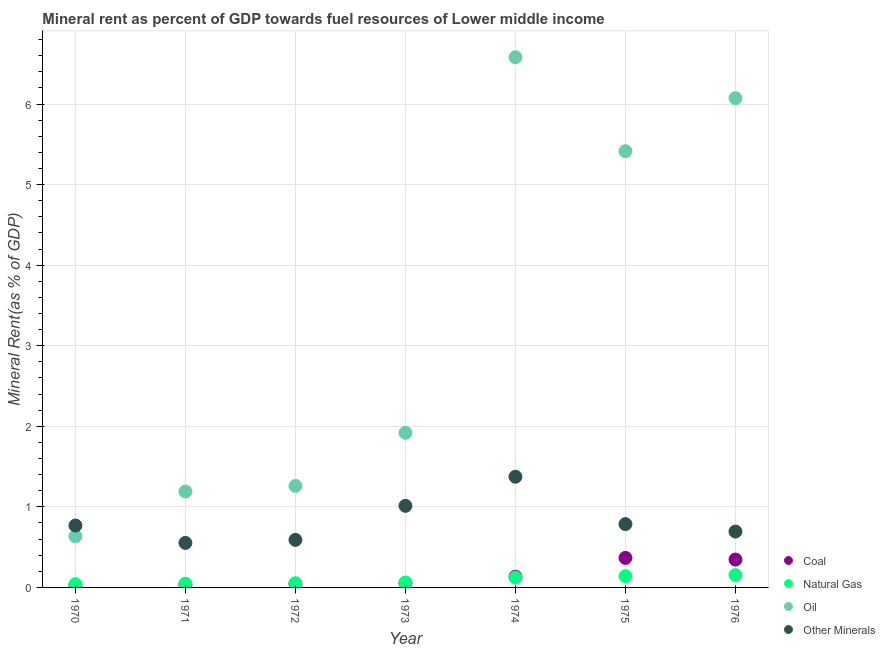Is the number of dotlines equal to the number of legend labels?
Provide a succinct answer. Yes. What is the  rent of other minerals in 1975?
Your response must be concise. 0.79. Across all years, what is the maximum natural gas rent?
Provide a succinct answer. 0.15. Across all years, what is the minimum  rent of other minerals?
Offer a terse response. 0.55. In which year was the  rent of other minerals maximum?
Keep it short and to the point. 1974. In which year was the  rent of other minerals minimum?
Offer a terse response. 1971. What is the total coal rent in the graph?
Offer a very short reply. 1. What is the difference between the natural gas rent in 1970 and that in 1975?
Your response must be concise. -0.1. What is the difference between the oil rent in 1976 and the natural gas rent in 1970?
Provide a succinct answer. 6.03. What is the average oil rent per year?
Keep it short and to the point. 3.3. In the year 1976, what is the difference between the coal rent and  rent of other minerals?
Offer a terse response. -0.35. In how many years, is the coal rent greater than 4.2 %?
Offer a terse response. 0. What is the ratio of the coal rent in 1972 to that in 1976?
Make the answer very short. 0.13. Is the difference between the coal rent in 1971 and 1976 greater than the difference between the  rent of other minerals in 1971 and 1976?
Give a very brief answer. No. What is the difference between the highest and the second highest coal rent?
Provide a short and direct response. 0.02. What is the difference between the highest and the lowest  rent of other minerals?
Your answer should be compact. 0.82. Is the oil rent strictly greater than the natural gas rent over the years?
Offer a terse response. Yes. Is the coal rent strictly less than the  rent of other minerals over the years?
Provide a short and direct response. Yes. How many years are there in the graph?
Provide a short and direct response. 7. What is the difference between two consecutive major ticks on the Y-axis?
Give a very brief answer. 1. Are the values on the major ticks of Y-axis written in scientific E-notation?
Give a very brief answer. No. Does the graph contain any zero values?
Keep it short and to the point. No. Does the graph contain grids?
Offer a very short reply. Yes. How many legend labels are there?
Make the answer very short. 4. How are the legend labels stacked?
Offer a very short reply. Vertical. What is the title of the graph?
Provide a short and direct response. Mineral rent as percent of GDP towards fuel resources of Lower middle income. What is the label or title of the Y-axis?
Make the answer very short. Mineral Rent(as % of GDP). What is the Mineral Rent(as % of GDP) of Coal in 1970?
Make the answer very short. 0.02. What is the Mineral Rent(as % of GDP) of Natural Gas in 1970?
Ensure brevity in your answer.  0.04. What is the Mineral Rent(as % of GDP) of Oil in 1970?
Offer a terse response. 0.63. What is the Mineral Rent(as % of GDP) of Other Minerals in 1970?
Ensure brevity in your answer.  0.77. What is the Mineral Rent(as % of GDP) in Coal in 1971?
Your answer should be compact. 0.04. What is the Mineral Rent(as % of GDP) in Natural Gas in 1971?
Give a very brief answer. 0.05. What is the Mineral Rent(as % of GDP) of Oil in 1971?
Your answer should be compact. 1.19. What is the Mineral Rent(as % of GDP) in Other Minerals in 1971?
Your answer should be very brief. 0.55. What is the Mineral Rent(as % of GDP) in Coal in 1972?
Ensure brevity in your answer.  0.04. What is the Mineral Rent(as % of GDP) in Natural Gas in 1972?
Your answer should be compact. 0.05. What is the Mineral Rent(as % of GDP) of Oil in 1972?
Keep it short and to the point. 1.26. What is the Mineral Rent(as % of GDP) of Other Minerals in 1972?
Offer a very short reply. 0.59. What is the Mineral Rent(as % of GDP) in Coal in 1973?
Keep it short and to the point. 0.05. What is the Mineral Rent(as % of GDP) of Natural Gas in 1973?
Make the answer very short. 0.06. What is the Mineral Rent(as % of GDP) in Oil in 1973?
Keep it short and to the point. 1.92. What is the Mineral Rent(as % of GDP) of Other Minerals in 1973?
Make the answer very short. 1.01. What is the Mineral Rent(as % of GDP) of Coal in 1974?
Provide a succinct answer. 0.13. What is the Mineral Rent(as % of GDP) of Natural Gas in 1974?
Offer a terse response. 0.12. What is the Mineral Rent(as % of GDP) of Oil in 1974?
Your response must be concise. 6.58. What is the Mineral Rent(as % of GDP) in Other Minerals in 1974?
Ensure brevity in your answer.  1.37. What is the Mineral Rent(as % of GDP) in Coal in 1975?
Your answer should be very brief. 0.37. What is the Mineral Rent(as % of GDP) of Natural Gas in 1975?
Offer a terse response. 0.14. What is the Mineral Rent(as % of GDP) of Oil in 1975?
Keep it short and to the point. 5.41. What is the Mineral Rent(as % of GDP) of Other Minerals in 1975?
Provide a succinct answer. 0.79. What is the Mineral Rent(as % of GDP) in Coal in 1976?
Your response must be concise. 0.35. What is the Mineral Rent(as % of GDP) of Natural Gas in 1976?
Ensure brevity in your answer.  0.15. What is the Mineral Rent(as % of GDP) in Oil in 1976?
Keep it short and to the point. 6.07. What is the Mineral Rent(as % of GDP) of Other Minerals in 1976?
Offer a terse response. 0.69. Across all years, what is the maximum Mineral Rent(as % of GDP) of Coal?
Keep it short and to the point. 0.37. Across all years, what is the maximum Mineral Rent(as % of GDP) of Natural Gas?
Your answer should be very brief. 0.15. Across all years, what is the maximum Mineral Rent(as % of GDP) in Oil?
Your response must be concise. 6.58. Across all years, what is the maximum Mineral Rent(as % of GDP) of Other Minerals?
Make the answer very short. 1.37. Across all years, what is the minimum Mineral Rent(as % of GDP) in Coal?
Make the answer very short. 0.02. Across all years, what is the minimum Mineral Rent(as % of GDP) of Natural Gas?
Give a very brief answer. 0.04. Across all years, what is the minimum Mineral Rent(as % of GDP) of Oil?
Keep it short and to the point. 0.63. Across all years, what is the minimum Mineral Rent(as % of GDP) of Other Minerals?
Provide a short and direct response. 0.55. What is the total Mineral Rent(as % of GDP) in Natural Gas in the graph?
Offer a terse response. 0.62. What is the total Mineral Rent(as % of GDP) in Oil in the graph?
Make the answer very short. 23.07. What is the total Mineral Rent(as % of GDP) of Other Minerals in the graph?
Make the answer very short. 5.78. What is the difference between the Mineral Rent(as % of GDP) in Coal in 1970 and that in 1971?
Give a very brief answer. -0.02. What is the difference between the Mineral Rent(as % of GDP) of Natural Gas in 1970 and that in 1971?
Offer a very short reply. -0. What is the difference between the Mineral Rent(as % of GDP) in Oil in 1970 and that in 1971?
Your response must be concise. -0.56. What is the difference between the Mineral Rent(as % of GDP) in Other Minerals in 1970 and that in 1971?
Provide a succinct answer. 0.22. What is the difference between the Mineral Rent(as % of GDP) of Coal in 1970 and that in 1972?
Give a very brief answer. -0.02. What is the difference between the Mineral Rent(as % of GDP) of Natural Gas in 1970 and that in 1972?
Your answer should be very brief. -0.01. What is the difference between the Mineral Rent(as % of GDP) of Oil in 1970 and that in 1972?
Provide a succinct answer. -0.62. What is the difference between the Mineral Rent(as % of GDP) in Other Minerals in 1970 and that in 1972?
Keep it short and to the point. 0.18. What is the difference between the Mineral Rent(as % of GDP) of Coal in 1970 and that in 1973?
Provide a succinct answer. -0.03. What is the difference between the Mineral Rent(as % of GDP) of Natural Gas in 1970 and that in 1973?
Your response must be concise. -0.02. What is the difference between the Mineral Rent(as % of GDP) of Oil in 1970 and that in 1973?
Make the answer very short. -1.28. What is the difference between the Mineral Rent(as % of GDP) of Other Minerals in 1970 and that in 1973?
Your answer should be very brief. -0.24. What is the difference between the Mineral Rent(as % of GDP) of Coal in 1970 and that in 1974?
Provide a short and direct response. -0.11. What is the difference between the Mineral Rent(as % of GDP) of Natural Gas in 1970 and that in 1974?
Ensure brevity in your answer.  -0.08. What is the difference between the Mineral Rent(as % of GDP) of Oil in 1970 and that in 1974?
Ensure brevity in your answer.  -5.95. What is the difference between the Mineral Rent(as % of GDP) in Other Minerals in 1970 and that in 1974?
Your answer should be very brief. -0.61. What is the difference between the Mineral Rent(as % of GDP) in Coal in 1970 and that in 1975?
Ensure brevity in your answer.  -0.35. What is the difference between the Mineral Rent(as % of GDP) of Natural Gas in 1970 and that in 1975?
Provide a short and direct response. -0.1. What is the difference between the Mineral Rent(as % of GDP) in Oil in 1970 and that in 1975?
Your answer should be very brief. -4.78. What is the difference between the Mineral Rent(as % of GDP) in Other Minerals in 1970 and that in 1975?
Your response must be concise. -0.02. What is the difference between the Mineral Rent(as % of GDP) of Coal in 1970 and that in 1976?
Offer a very short reply. -0.33. What is the difference between the Mineral Rent(as % of GDP) of Natural Gas in 1970 and that in 1976?
Your answer should be compact. -0.11. What is the difference between the Mineral Rent(as % of GDP) of Oil in 1970 and that in 1976?
Your answer should be very brief. -5.44. What is the difference between the Mineral Rent(as % of GDP) in Other Minerals in 1970 and that in 1976?
Offer a terse response. 0.08. What is the difference between the Mineral Rent(as % of GDP) in Coal in 1971 and that in 1972?
Your answer should be compact. -0.01. What is the difference between the Mineral Rent(as % of GDP) of Natural Gas in 1971 and that in 1972?
Offer a very short reply. -0.01. What is the difference between the Mineral Rent(as % of GDP) of Oil in 1971 and that in 1972?
Ensure brevity in your answer.  -0.07. What is the difference between the Mineral Rent(as % of GDP) of Other Minerals in 1971 and that in 1972?
Your answer should be very brief. -0.04. What is the difference between the Mineral Rent(as % of GDP) in Coal in 1971 and that in 1973?
Ensure brevity in your answer.  -0.02. What is the difference between the Mineral Rent(as % of GDP) of Natural Gas in 1971 and that in 1973?
Provide a succinct answer. -0.02. What is the difference between the Mineral Rent(as % of GDP) in Oil in 1971 and that in 1973?
Your answer should be compact. -0.73. What is the difference between the Mineral Rent(as % of GDP) in Other Minerals in 1971 and that in 1973?
Offer a very short reply. -0.46. What is the difference between the Mineral Rent(as % of GDP) of Coal in 1971 and that in 1974?
Provide a short and direct response. -0.1. What is the difference between the Mineral Rent(as % of GDP) in Natural Gas in 1971 and that in 1974?
Make the answer very short. -0.08. What is the difference between the Mineral Rent(as % of GDP) in Oil in 1971 and that in 1974?
Offer a terse response. -5.39. What is the difference between the Mineral Rent(as % of GDP) in Other Minerals in 1971 and that in 1974?
Keep it short and to the point. -0.82. What is the difference between the Mineral Rent(as % of GDP) of Coal in 1971 and that in 1975?
Provide a succinct answer. -0.33. What is the difference between the Mineral Rent(as % of GDP) of Natural Gas in 1971 and that in 1975?
Offer a terse response. -0.09. What is the difference between the Mineral Rent(as % of GDP) in Oil in 1971 and that in 1975?
Ensure brevity in your answer.  -4.22. What is the difference between the Mineral Rent(as % of GDP) in Other Minerals in 1971 and that in 1975?
Provide a short and direct response. -0.23. What is the difference between the Mineral Rent(as % of GDP) of Coal in 1971 and that in 1976?
Provide a succinct answer. -0.31. What is the difference between the Mineral Rent(as % of GDP) in Natural Gas in 1971 and that in 1976?
Provide a succinct answer. -0.11. What is the difference between the Mineral Rent(as % of GDP) of Oil in 1971 and that in 1976?
Give a very brief answer. -4.88. What is the difference between the Mineral Rent(as % of GDP) in Other Minerals in 1971 and that in 1976?
Give a very brief answer. -0.14. What is the difference between the Mineral Rent(as % of GDP) in Coal in 1972 and that in 1973?
Provide a short and direct response. -0.01. What is the difference between the Mineral Rent(as % of GDP) in Natural Gas in 1972 and that in 1973?
Your answer should be compact. -0.01. What is the difference between the Mineral Rent(as % of GDP) of Oil in 1972 and that in 1973?
Offer a terse response. -0.66. What is the difference between the Mineral Rent(as % of GDP) in Other Minerals in 1972 and that in 1973?
Ensure brevity in your answer.  -0.42. What is the difference between the Mineral Rent(as % of GDP) of Coal in 1972 and that in 1974?
Your answer should be very brief. -0.09. What is the difference between the Mineral Rent(as % of GDP) in Natural Gas in 1972 and that in 1974?
Your response must be concise. -0.07. What is the difference between the Mineral Rent(as % of GDP) of Oil in 1972 and that in 1974?
Offer a very short reply. -5.32. What is the difference between the Mineral Rent(as % of GDP) of Other Minerals in 1972 and that in 1974?
Offer a very short reply. -0.78. What is the difference between the Mineral Rent(as % of GDP) in Coal in 1972 and that in 1975?
Offer a terse response. -0.32. What is the difference between the Mineral Rent(as % of GDP) in Natural Gas in 1972 and that in 1975?
Your answer should be very brief. -0.09. What is the difference between the Mineral Rent(as % of GDP) in Oil in 1972 and that in 1975?
Give a very brief answer. -4.15. What is the difference between the Mineral Rent(as % of GDP) in Other Minerals in 1972 and that in 1975?
Provide a short and direct response. -0.2. What is the difference between the Mineral Rent(as % of GDP) in Coal in 1972 and that in 1976?
Give a very brief answer. -0.3. What is the difference between the Mineral Rent(as % of GDP) of Natural Gas in 1972 and that in 1976?
Your answer should be very brief. -0.1. What is the difference between the Mineral Rent(as % of GDP) of Oil in 1972 and that in 1976?
Provide a succinct answer. -4.81. What is the difference between the Mineral Rent(as % of GDP) of Other Minerals in 1972 and that in 1976?
Ensure brevity in your answer.  -0.1. What is the difference between the Mineral Rent(as % of GDP) of Coal in 1973 and that in 1974?
Provide a succinct answer. -0.08. What is the difference between the Mineral Rent(as % of GDP) of Natural Gas in 1973 and that in 1974?
Provide a short and direct response. -0.06. What is the difference between the Mineral Rent(as % of GDP) in Oil in 1973 and that in 1974?
Keep it short and to the point. -4.66. What is the difference between the Mineral Rent(as % of GDP) in Other Minerals in 1973 and that in 1974?
Make the answer very short. -0.36. What is the difference between the Mineral Rent(as % of GDP) of Coal in 1973 and that in 1975?
Your response must be concise. -0.31. What is the difference between the Mineral Rent(as % of GDP) in Natural Gas in 1973 and that in 1975?
Give a very brief answer. -0.08. What is the difference between the Mineral Rent(as % of GDP) of Oil in 1973 and that in 1975?
Offer a very short reply. -3.5. What is the difference between the Mineral Rent(as % of GDP) in Other Minerals in 1973 and that in 1975?
Offer a terse response. 0.23. What is the difference between the Mineral Rent(as % of GDP) in Coal in 1973 and that in 1976?
Provide a succinct answer. -0.29. What is the difference between the Mineral Rent(as % of GDP) in Natural Gas in 1973 and that in 1976?
Your answer should be compact. -0.09. What is the difference between the Mineral Rent(as % of GDP) in Oil in 1973 and that in 1976?
Provide a succinct answer. -4.15. What is the difference between the Mineral Rent(as % of GDP) in Other Minerals in 1973 and that in 1976?
Keep it short and to the point. 0.32. What is the difference between the Mineral Rent(as % of GDP) of Coal in 1974 and that in 1975?
Provide a succinct answer. -0.23. What is the difference between the Mineral Rent(as % of GDP) in Natural Gas in 1974 and that in 1975?
Provide a succinct answer. -0.02. What is the difference between the Mineral Rent(as % of GDP) of Oil in 1974 and that in 1975?
Offer a terse response. 1.17. What is the difference between the Mineral Rent(as % of GDP) of Other Minerals in 1974 and that in 1975?
Make the answer very short. 0.59. What is the difference between the Mineral Rent(as % of GDP) of Coal in 1974 and that in 1976?
Keep it short and to the point. -0.21. What is the difference between the Mineral Rent(as % of GDP) in Natural Gas in 1974 and that in 1976?
Offer a very short reply. -0.03. What is the difference between the Mineral Rent(as % of GDP) in Oil in 1974 and that in 1976?
Your answer should be compact. 0.51. What is the difference between the Mineral Rent(as % of GDP) in Other Minerals in 1974 and that in 1976?
Your answer should be compact. 0.68. What is the difference between the Mineral Rent(as % of GDP) of Coal in 1975 and that in 1976?
Offer a very short reply. 0.02. What is the difference between the Mineral Rent(as % of GDP) of Natural Gas in 1975 and that in 1976?
Give a very brief answer. -0.01. What is the difference between the Mineral Rent(as % of GDP) of Oil in 1975 and that in 1976?
Provide a succinct answer. -0.66. What is the difference between the Mineral Rent(as % of GDP) of Other Minerals in 1975 and that in 1976?
Make the answer very short. 0.09. What is the difference between the Mineral Rent(as % of GDP) of Coal in 1970 and the Mineral Rent(as % of GDP) of Natural Gas in 1971?
Your answer should be very brief. -0.03. What is the difference between the Mineral Rent(as % of GDP) of Coal in 1970 and the Mineral Rent(as % of GDP) of Oil in 1971?
Provide a succinct answer. -1.17. What is the difference between the Mineral Rent(as % of GDP) in Coal in 1970 and the Mineral Rent(as % of GDP) in Other Minerals in 1971?
Make the answer very short. -0.53. What is the difference between the Mineral Rent(as % of GDP) in Natural Gas in 1970 and the Mineral Rent(as % of GDP) in Oil in 1971?
Provide a succinct answer. -1.15. What is the difference between the Mineral Rent(as % of GDP) of Natural Gas in 1970 and the Mineral Rent(as % of GDP) of Other Minerals in 1971?
Give a very brief answer. -0.51. What is the difference between the Mineral Rent(as % of GDP) in Oil in 1970 and the Mineral Rent(as % of GDP) in Other Minerals in 1971?
Your answer should be very brief. 0.08. What is the difference between the Mineral Rent(as % of GDP) of Coal in 1970 and the Mineral Rent(as % of GDP) of Natural Gas in 1972?
Offer a terse response. -0.03. What is the difference between the Mineral Rent(as % of GDP) of Coal in 1970 and the Mineral Rent(as % of GDP) of Oil in 1972?
Your response must be concise. -1.24. What is the difference between the Mineral Rent(as % of GDP) in Coal in 1970 and the Mineral Rent(as % of GDP) in Other Minerals in 1972?
Your answer should be compact. -0.57. What is the difference between the Mineral Rent(as % of GDP) in Natural Gas in 1970 and the Mineral Rent(as % of GDP) in Oil in 1972?
Make the answer very short. -1.22. What is the difference between the Mineral Rent(as % of GDP) of Natural Gas in 1970 and the Mineral Rent(as % of GDP) of Other Minerals in 1972?
Your answer should be compact. -0.55. What is the difference between the Mineral Rent(as % of GDP) of Oil in 1970 and the Mineral Rent(as % of GDP) of Other Minerals in 1972?
Keep it short and to the point. 0.04. What is the difference between the Mineral Rent(as % of GDP) of Coal in 1970 and the Mineral Rent(as % of GDP) of Natural Gas in 1973?
Give a very brief answer. -0.04. What is the difference between the Mineral Rent(as % of GDP) in Coal in 1970 and the Mineral Rent(as % of GDP) in Oil in 1973?
Your response must be concise. -1.9. What is the difference between the Mineral Rent(as % of GDP) of Coal in 1970 and the Mineral Rent(as % of GDP) of Other Minerals in 1973?
Offer a terse response. -0.99. What is the difference between the Mineral Rent(as % of GDP) of Natural Gas in 1970 and the Mineral Rent(as % of GDP) of Oil in 1973?
Your response must be concise. -1.88. What is the difference between the Mineral Rent(as % of GDP) in Natural Gas in 1970 and the Mineral Rent(as % of GDP) in Other Minerals in 1973?
Ensure brevity in your answer.  -0.97. What is the difference between the Mineral Rent(as % of GDP) in Oil in 1970 and the Mineral Rent(as % of GDP) in Other Minerals in 1973?
Your response must be concise. -0.38. What is the difference between the Mineral Rent(as % of GDP) in Coal in 1970 and the Mineral Rent(as % of GDP) in Natural Gas in 1974?
Your answer should be very brief. -0.1. What is the difference between the Mineral Rent(as % of GDP) of Coal in 1970 and the Mineral Rent(as % of GDP) of Oil in 1974?
Make the answer very short. -6.56. What is the difference between the Mineral Rent(as % of GDP) in Coal in 1970 and the Mineral Rent(as % of GDP) in Other Minerals in 1974?
Your answer should be very brief. -1.35. What is the difference between the Mineral Rent(as % of GDP) in Natural Gas in 1970 and the Mineral Rent(as % of GDP) in Oil in 1974?
Offer a very short reply. -6.54. What is the difference between the Mineral Rent(as % of GDP) in Natural Gas in 1970 and the Mineral Rent(as % of GDP) in Other Minerals in 1974?
Offer a very short reply. -1.33. What is the difference between the Mineral Rent(as % of GDP) in Oil in 1970 and the Mineral Rent(as % of GDP) in Other Minerals in 1974?
Ensure brevity in your answer.  -0.74. What is the difference between the Mineral Rent(as % of GDP) of Coal in 1970 and the Mineral Rent(as % of GDP) of Natural Gas in 1975?
Make the answer very short. -0.12. What is the difference between the Mineral Rent(as % of GDP) in Coal in 1970 and the Mineral Rent(as % of GDP) in Oil in 1975?
Offer a very short reply. -5.39. What is the difference between the Mineral Rent(as % of GDP) in Coal in 1970 and the Mineral Rent(as % of GDP) in Other Minerals in 1975?
Provide a short and direct response. -0.77. What is the difference between the Mineral Rent(as % of GDP) in Natural Gas in 1970 and the Mineral Rent(as % of GDP) in Oil in 1975?
Provide a short and direct response. -5.37. What is the difference between the Mineral Rent(as % of GDP) in Natural Gas in 1970 and the Mineral Rent(as % of GDP) in Other Minerals in 1975?
Provide a short and direct response. -0.74. What is the difference between the Mineral Rent(as % of GDP) of Oil in 1970 and the Mineral Rent(as % of GDP) of Other Minerals in 1975?
Ensure brevity in your answer.  -0.15. What is the difference between the Mineral Rent(as % of GDP) in Coal in 1970 and the Mineral Rent(as % of GDP) in Natural Gas in 1976?
Give a very brief answer. -0.13. What is the difference between the Mineral Rent(as % of GDP) in Coal in 1970 and the Mineral Rent(as % of GDP) in Oil in 1976?
Provide a succinct answer. -6.05. What is the difference between the Mineral Rent(as % of GDP) in Coal in 1970 and the Mineral Rent(as % of GDP) in Other Minerals in 1976?
Offer a terse response. -0.67. What is the difference between the Mineral Rent(as % of GDP) in Natural Gas in 1970 and the Mineral Rent(as % of GDP) in Oil in 1976?
Give a very brief answer. -6.03. What is the difference between the Mineral Rent(as % of GDP) in Natural Gas in 1970 and the Mineral Rent(as % of GDP) in Other Minerals in 1976?
Your answer should be very brief. -0.65. What is the difference between the Mineral Rent(as % of GDP) in Oil in 1970 and the Mineral Rent(as % of GDP) in Other Minerals in 1976?
Keep it short and to the point. -0.06. What is the difference between the Mineral Rent(as % of GDP) in Coal in 1971 and the Mineral Rent(as % of GDP) in Natural Gas in 1972?
Provide a short and direct response. -0.02. What is the difference between the Mineral Rent(as % of GDP) of Coal in 1971 and the Mineral Rent(as % of GDP) of Oil in 1972?
Keep it short and to the point. -1.22. What is the difference between the Mineral Rent(as % of GDP) of Coal in 1971 and the Mineral Rent(as % of GDP) of Other Minerals in 1972?
Provide a succinct answer. -0.55. What is the difference between the Mineral Rent(as % of GDP) in Natural Gas in 1971 and the Mineral Rent(as % of GDP) in Oil in 1972?
Offer a terse response. -1.21. What is the difference between the Mineral Rent(as % of GDP) in Natural Gas in 1971 and the Mineral Rent(as % of GDP) in Other Minerals in 1972?
Ensure brevity in your answer.  -0.54. What is the difference between the Mineral Rent(as % of GDP) of Oil in 1971 and the Mineral Rent(as % of GDP) of Other Minerals in 1972?
Your answer should be compact. 0.6. What is the difference between the Mineral Rent(as % of GDP) of Coal in 1971 and the Mineral Rent(as % of GDP) of Natural Gas in 1973?
Your answer should be compact. -0.02. What is the difference between the Mineral Rent(as % of GDP) of Coal in 1971 and the Mineral Rent(as % of GDP) of Oil in 1973?
Provide a succinct answer. -1.88. What is the difference between the Mineral Rent(as % of GDP) in Coal in 1971 and the Mineral Rent(as % of GDP) in Other Minerals in 1973?
Your answer should be very brief. -0.98. What is the difference between the Mineral Rent(as % of GDP) of Natural Gas in 1971 and the Mineral Rent(as % of GDP) of Oil in 1973?
Ensure brevity in your answer.  -1.87. What is the difference between the Mineral Rent(as % of GDP) of Natural Gas in 1971 and the Mineral Rent(as % of GDP) of Other Minerals in 1973?
Give a very brief answer. -0.97. What is the difference between the Mineral Rent(as % of GDP) of Oil in 1971 and the Mineral Rent(as % of GDP) of Other Minerals in 1973?
Your answer should be compact. 0.18. What is the difference between the Mineral Rent(as % of GDP) of Coal in 1971 and the Mineral Rent(as % of GDP) of Natural Gas in 1974?
Keep it short and to the point. -0.09. What is the difference between the Mineral Rent(as % of GDP) in Coal in 1971 and the Mineral Rent(as % of GDP) in Oil in 1974?
Keep it short and to the point. -6.54. What is the difference between the Mineral Rent(as % of GDP) of Coal in 1971 and the Mineral Rent(as % of GDP) of Other Minerals in 1974?
Your response must be concise. -1.34. What is the difference between the Mineral Rent(as % of GDP) in Natural Gas in 1971 and the Mineral Rent(as % of GDP) in Oil in 1974?
Keep it short and to the point. -6.53. What is the difference between the Mineral Rent(as % of GDP) of Natural Gas in 1971 and the Mineral Rent(as % of GDP) of Other Minerals in 1974?
Provide a short and direct response. -1.33. What is the difference between the Mineral Rent(as % of GDP) in Oil in 1971 and the Mineral Rent(as % of GDP) in Other Minerals in 1974?
Your answer should be very brief. -0.18. What is the difference between the Mineral Rent(as % of GDP) of Coal in 1971 and the Mineral Rent(as % of GDP) of Natural Gas in 1975?
Offer a terse response. -0.1. What is the difference between the Mineral Rent(as % of GDP) in Coal in 1971 and the Mineral Rent(as % of GDP) in Oil in 1975?
Offer a terse response. -5.38. What is the difference between the Mineral Rent(as % of GDP) in Coal in 1971 and the Mineral Rent(as % of GDP) in Other Minerals in 1975?
Your answer should be very brief. -0.75. What is the difference between the Mineral Rent(as % of GDP) of Natural Gas in 1971 and the Mineral Rent(as % of GDP) of Oil in 1975?
Offer a terse response. -5.37. What is the difference between the Mineral Rent(as % of GDP) in Natural Gas in 1971 and the Mineral Rent(as % of GDP) in Other Minerals in 1975?
Ensure brevity in your answer.  -0.74. What is the difference between the Mineral Rent(as % of GDP) in Oil in 1971 and the Mineral Rent(as % of GDP) in Other Minerals in 1975?
Offer a terse response. 0.4. What is the difference between the Mineral Rent(as % of GDP) in Coal in 1971 and the Mineral Rent(as % of GDP) in Natural Gas in 1976?
Offer a terse response. -0.12. What is the difference between the Mineral Rent(as % of GDP) of Coal in 1971 and the Mineral Rent(as % of GDP) of Oil in 1976?
Provide a succinct answer. -6.04. What is the difference between the Mineral Rent(as % of GDP) of Coal in 1971 and the Mineral Rent(as % of GDP) of Other Minerals in 1976?
Offer a very short reply. -0.66. What is the difference between the Mineral Rent(as % of GDP) in Natural Gas in 1971 and the Mineral Rent(as % of GDP) in Oil in 1976?
Provide a short and direct response. -6.03. What is the difference between the Mineral Rent(as % of GDP) in Natural Gas in 1971 and the Mineral Rent(as % of GDP) in Other Minerals in 1976?
Make the answer very short. -0.65. What is the difference between the Mineral Rent(as % of GDP) in Oil in 1971 and the Mineral Rent(as % of GDP) in Other Minerals in 1976?
Provide a short and direct response. 0.5. What is the difference between the Mineral Rent(as % of GDP) of Coal in 1972 and the Mineral Rent(as % of GDP) of Natural Gas in 1973?
Your answer should be compact. -0.02. What is the difference between the Mineral Rent(as % of GDP) of Coal in 1972 and the Mineral Rent(as % of GDP) of Oil in 1973?
Your answer should be very brief. -1.87. What is the difference between the Mineral Rent(as % of GDP) of Coal in 1972 and the Mineral Rent(as % of GDP) of Other Minerals in 1973?
Your answer should be compact. -0.97. What is the difference between the Mineral Rent(as % of GDP) in Natural Gas in 1972 and the Mineral Rent(as % of GDP) in Oil in 1973?
Offer a terse response. -1.87. What is the difference between the Mineral Rent(as % of GDP) of Natural Gas in 1972 and the Mineral Rent(as % of GDP) of Other Minerals in 1973?
Provide a succinct answer. -0.96. What is the difference between the Mineral Rent(as % of GDP) in Oil in 1972 and the Mineral Rent(as % of GDP) in Other Minerals in 1973?
Make the answer very short. 0.25. What is the difference between the Mineral Rent(as % of GDP) of Coal in 1972 and the Mineral Rent(as % of GDP) of Natural Gas in 1974?
Make the answer very short. -0.08. What is the difference between the Mineral Rent(as % of GDP) of Coal in 1972 and the Mineral Rent(as % of GDP) of Oil in 1974?
Your answer should be compact. -6.54. What is the difference between the Mineral Rent(as % of GDP) of Coal in 1972 and the Mineral Rent(as % of GDP) of Other Minerals in 1974?
Provide a succinct answer. -1.33. What is the difference between the Mineral Rent(as % of GDP) in Natural Gas in 1972 and the Mineral Rent(as % of GDP) in Oil in 1974?
Make the answer very short. -6.53. What is the difference between the Mineral Rent(as % of GDP) in Natural Gas in 1972 and the Mineral Rent(as % of GDP) in Other Minerals in 1974?
Your response must be concise. -1.32. What is the difference between the Mineral Rent(as % of GDP) of Oil in 1972 and the Mineral Rent(as % of GDP) of Other Minerals in 1974?
Give a very brief answer. -0.11. What is the difference between the Mineral Rent(as % of GDP) of Coal in 1972 and the Mineral Rent(as % of GDP) of Natural Gas in 1975?
Make the answer very short. -0.1. What is the difference between the Mineral Rent(as % of GDP) in Coal in 1972 and the Mineral Rent(as % of GDP) in Oil in 1975?
Keep it short and to the point. -5.37. What is the difference between the Mineral Rent(as % of GDP) of Coal in 1972 and the Mineral Rent(as % of GDP) of Other Minerals in 1975?
Provide a succinct answer. -0.74. What is the difference between the Mineral Rent(as % of GDP) in Natural Gas in 1972 and the Mineral Rent(as % of GDP) in Oil in 1975?
Offer a very short reply. -5.36. What is the difference between the Mineral Rent(as % of GDP) of Natural Gas in 1972 and the Mineral Rent(as % of GDP) of Other Minerals in 1975?
Provide a short and direct response. -0.73. What is the difference between the Mineral Rent(as % of GDP) in Oil in 1972 and the Mineral Rent(as % of GDP) in Other Minerals in 1975?
Provide a short and direct response. 0.47. What is the difference between the Mineral Rent(as % of GDP) in Coal in 1972 and the Mineral Rent(as % of GDP) in Natural Gas in 1976?
Keep it short and to the point. -0.11. What is the difference between the Mineral Rent(as % of GDP) in Coal in 1972 and the Mineral Rent(as % of GDP) in Oil in 1976?
Keep it short and to the point. -6.03. What is the difference between the Mineral Rent(as % of GDP) in Coal in 1972 and the Mineral Rent(as % of GDP) in Other Minerals in 1976?
Ensure brevity in your answer.  -0.65. What is the difference between the Mineral Rent(as % of GDP) of Natural Gas in 1972 and the Mineral Rent(as % of GDP) of Oil in 1976?
Your answer should be compact. -6.02. What is the difference between the Mineral Rent(as % of GDP) of Natural Gas in 1972 and the Mineral Rent(as % of GDP) of Other Minerals in 1976?
Ensure brevity in your answer.  -0.64. What is the difference between the Mineral Rent(as % of GDP) in Oil in 1972 and the Mineral Rent(as % of GDP) in Other Minerals in 1976?
Your response must be concise. 0.57. What is the difference between the Mineral Rent(as % of GDP) in Coal in 1973 and the Mineral Rent(as % of GDP) in Natural Gas in 1974?
Keep it short and to the point. -0.07. What is the difference between the Mineral Rent(as % of GDP) of Coal in 1973 and the Mineral Rent(as % of GDP) of Oil in 1974?
Provide a succinct answer. -6.53. What is the difference between the Mineral Rent(as % of GDP) in Coal in 1973 and the Mineral Rent(as % of GDP) in Other Minerals in 1974?
Your answer should be very brief. -1.32. What is the difference between the Mineral Rent(as % of GDP) of Natural Gas in 1973 and the Mineral Rent(as % of GDP) of Oil in 1974?
Your answer should be very brief. -6.52. What is the difference between the Mineral Rent(as % of GDP) of Natural Gas in 1973 and the Mineral Rent(as % of GDP) of Other Minerals in 1974?
Your answer should be compact. -1.31. What is the difference between the Mineral Rent(as % of GDP) of Oil in 1973 and the Mineral Rent(as % of GDP) of Other Minerals in 1974?
Your answer should be compact. 0.54. What is the difference between the Mineral Rent(as % of GDP) in Coal in 1973 and the Mineral Rent(as % of GDP) in Natural Gas in 1975?
Provide a short and direct response. -0.09. What is the difference between the Mineral Rent(as % of GDP) of Coal in 1973 and the Mineral Rent(as % of GDP) of Oil in 1975?
Give a very brief answer. -5.36. What is the difference between the Mineral Rent(as % of GDP) in Coal in 1973 and the Mineral Rent(as % of GDP) in Other Minerals in 1975?
Provide a succinct answer. -0.73. What is the difference between the Mineral Rent(as % of GDP) in Natural Gas in 1973 and the Mineral Rent(as % of GDP) in Oil in 1975?
Keep it short and to the point. -5.35. What is the difference between the Mineral Rent(as % of GDP) in Natural Gas in 1973 and the Mineral Rent(as % of GDP) in Other Minerals in 1975?
Provide a short and direct response. -0.72. What is the difference between the Mineral Rent(as % of GDP) in Oil in 1973 and the Mineral Rent(as % of GDP) in Other Minerals in 1975?
Your answer should be very brief. 1.13. What is the difference between the Mineral Rent(as % of GDP) of Coal in 1973 and the Mineral Rent(as % of GDP) of Natural Gas in 1976?
Your response must be concise. -0.1. What is the difference between the Mineral Rent(as % of GDP) in Coal in 1973 and the Mineral Rent(as % of GDP) in Oil in 1976?
Provide a short and direct response. -6.02. What is the difference between the Mineral Rent(as % of GDP) in Coal in 1973 and the Mineral Rent(as % of GDP) in Other Minerals in 1976?
Give a very brief answer. -0.64. What is the difference between the Mineral Rent(as % of GDP) of Natural Gas in 1973 and the Mineral Rent(as % of GDP) of Oil in 1976?
Make the answer very short. -6.01. What is the difference between the Mineral Rent(as % of GDP) in Natural Gas in 1973 and the Mineral Rent(as % of GDP) in Other Minerals in 1976?
Offer a terse response. -0.63. What is the difference between the Mineral Rent(as % of GDP) of Oil in 1973 and the Mineral Rent(as % of GDP) of Other Minerals in 1976?
Provide a short and direct response. 1.23. What is the difference between the Mineral Rent(as % of GDP) of Coal in 1974 and the Mineral Rent(as % of GDP) of Natural Gas in 1975?
Give a very brief answer. -0.01. What is the difference between the Mineral Rent(as % of GDP) of Coal in 1974 and the Mineral Rent(as % of GDP) of Oil in 1975?
Provide a short and direct response. -5.28. What is the difference between the Mineral Rent(as % of GDP) of Coal in 1974 and the Mineral Rent(as % of GDP) of Other Minerals in 1975?
Ensure brevity in your answer.  -0.65. What is the difference between the Mineral Rent(as % of GDP) in Natural Gas in 1974 and the Mineral Rent(as % of GDP) in Oil in 1975?
Your response must be concise. -5.29. What is the difference between the Mineral Rent(as % of GDP) in Natural Gas in 1974 and the Mineral Rent(as % of GDP) in Other Minerals in 1975?
Your answer should be compact. -0.66. What is the difference between the Mineral Rent(as % of GDP) of Oil in 1974 and the Mineral Rent(as % of GDP) of Other Minerals in 1975?
Provide a short and direct response. 5.79. What is the difference between the Mineral Rent(as % of GDP) of Coal in 1974 and the Mineral Rent(as % of GDP) of Natural Gas in 1976?
Ensure brevity in your answer.  -0.02. What is the difference between the Mineral Rent(as % of GDP) of Coal in 1974 and the Mineral Rent(as % of GDP) of Oil in 1976?
Make the answer very short. -5.94. What is the difference between the Mineral Rent(as % of GDP) of Coal in 1974 and the Mineral Rent(as % of GDP) of Other Minerals in 1976?
Provide a short and direct response. -0.56. What is the difference between the Mineral Rent(as % of GDP) in Natural Gas in 1974 and the Mineral Rent(as % of GDP) in Oil in 1976?
Offer a terse response. -5.95. What is the difference between the Mineral Rent(as % of GDP) in Natural Gas in 1974 and the Mineral Rent(as % of GDP) in Other Minerals in 1976?
Give a very brief answer. -0.57. What is the difference between the Mineral Rent(as % of GDP) in Oil in 1974 and the Mineral Rent(as % of GDP) in Other Minerals in 1976?
Provide a succinct answer. 5.89. What is the difference between the Mineral Rent(as % of GDP) in Coal in 1975 and the Mineral Rent(as % of GDP) in Natural Gas in 1976?
Make the answer very short. 0.21. What is the difference between the Mineral Rent(as % of GDP) in Coal in 1975 and the Mineral Rent(as % of GDP) in Oil in 1976?
Give a very brief answer. -5.71. What is the difference between the Mineral Rent(as % of GDP) in Coal in 1975 and the Mineral Rent(as % of GDP) in Other Minerals in 1976?
Ensure brevity in your answer.  -0.33. What is the difference between the Mineral Rent(as % of GDP) in Natural Gas in 1975 and the Mineral Rent(as % of GDP) in Oil in 1976?
Provide a succinct answer. -5.93. What is the difference between the Mineral Rent(as % of GDP) in Natural Gas in 1975 and the Mineral Rent(as % of GDP) in Other Minerals in 1976?
Make the answer very short. -0.55. What is the difference between the Mineral Rent(as % of GDP) in Oil in 1975 and the Mineral Rent(as % of GDP) in Other Minerals in 1976?
Offer a very short reply. 4.72. What is the average Mineral Rent(as % of GDP) in Coal per year?
Provide a succinct answer. 0.14. What is the average Mineral Rent(as % of GDP) of Natural Gas per year?
Provide a short and direct response. 0.09. What is the average Mineral Rent(as % of GDP) of Oil per year?
Your answer should be compact. 3.3. What is the average Mineral Rent(as % of GDP) of Other Minerals per year?
Offer a terse response. 0.83. In the year 1970, what is the difference between the Mineral Rent(as % of GDP) in Coal and Mineral Rent(as % of GDP) in Natural Gas?
Your answer should be very brief. -0.02. In the year 1970, what is the difference between the Mineral Rent(as % of GDP) in Coal and Mineral Rent(as % of GDP) in Oil?
Provide a short and direct response. -0.61. In the year 1970, what is the difference between the Mineral Rent(as % of GDP) in Coal and Mineral Rent(as % of GDP) in Other Minerals?
Make the answer very short. -0.75. In the year 1970, what is the difference between the Mineral Rent(as % of GDP) in Natural Gas and Mineral Rent(as % of GDP) in Oil?
Give a very brief answer. -0.59. In the year 1970, what is the difference between the Mineral Rent(as % of GDP) in Natural Gas and Mineral Rent(as % of GDP) in Other Minerals?
Make the answer very short. -0.73. In the year 1970, what is the difference between the Mineral Rent(as % of GDP) in Oil and Mineral Rent(as % of GDP) in Other Minerals?
Provide a succinct answer. -0.13. In the year 1971, what is the difference between the Mineral Rent(as % of GDP) in Coal and Mineral Rent(as % of GDP) in Natural Gas?
Your answer should be compact. -0.01. In the year 1971, what is the difference between the Mineral Rent(as % of GDP) in Coal and Mineral Rent(as % of GDP) in Oil?
Make the answer very short. -1.15. In the year 1971, what is the difference between the Mineral Rent(as % of GDP) of Coal and Mineral Rent(as % of GDP) of Other Minerals?
Make the answer very short. -0.52. In the year 1971, what is the difference between the Mineral Rent(as % of GDP) of Natural Gas and Mineral Rent(as % of GDP) of Oil?
Provide a succinct answer. -1.14. In the year 1971, what is the difference between the Mineral Rent(as % of GDP) of Natural Gas and Mineral Rent(as % of GDP) of Other Minerals?
Ensure brevity in your answer.  -0.51. In the year 1971, what is the difference between the Mineral Rent(as % of GDP) of Oil and Mineral Rent(as % of GDP) of Other Minerals?
Your answer should be very brief. 0.64. In the year 1972, what is the difference between the Mineral Rent(as % of GDP) in Coal and Mineral Rent(as % of GDP) in Natural Gas?
Provide a succinct answer. -0.01. In the year 1972, what is the difference between the Mineral Rent(as % of GDP) of Coal and Mineral Rent(as % of GDP) of Oil?
Your answer should be very brief. -1.22. In the year 1972, what is the difference between the Mineral Rent(as % of GDP) in Coal and Mineral Rent(as % of GDP) in Other Minerals?
Offer a very short reply. -0.55. In the year 1972, what is the difference between the Mineral Rent(as % of GDP) of Natural Gas and Mineral Rent(as % of GDP) of Oil?
Keep it short and to the point. -1.21. In the year 1972, what is the difference between the Mineral Rent(as % of GDP) in Natural Gas and Mineral Rent(as % of GDP) in Other Minerals?
Offer a terse response. -0.54. In the year 1972, what is the difference between the Mineral Rent(as % of GDP) in Oil and Mineral Rent(as % of GDP) in Other Minerals?
Give a very brief answer. 0.67. In the year 1973, what is the difference between the Mineral Rent(as % of GDP) of Coal and Mineral Rent(as % of GDP) of Natural Gas?
Your response must be concise. -0.01. In the year 1973, what is the difference between the Mineral Rent(as % of GDP) in Coal and Mineral Rent(as % of GDP) in Oil?
Keep it short and to the point. -1.86. In the year 1973, what is the difference between the Mineral Rent(as % of GDP) in Coal and Mineral Rent(as % of GDP) in Other Minerals?
Ensure brevity in your answer.  -0.96. In the year 1973, what is the difference between the Mineral Rent(as % of GDP) of Natural Gas and Mineral Rent(as % of GDP) of Oil?
Provide a short and direct response. -1.86. In the year 1973, what is the difference between the Mineral Rent(as % of GDP) of Natural Gas and Mineral Rent(as % of GDP) of Other Minerals?
Make the answer very short. -0.95. In the year 1973, what is the difference between the Mineral Rent(as % of GDP) in Oil and Mineral Rent(as % of GDP) in Other Minerals?
Offer a very short reply. 0.91. In the year 1974, what is the difference between the Mineral Rent(as % of GDP) of Coal and Mineral Rent(as % of GDP) of Natural Gas?
Offer a terse response. 0.01. In the year 1974, what is the difference between the Mineral Rent(as % of GDP) in Coal and Mineral Rent(as % of GDP) in Oil?
Make the answer very short. -6.45. In the year 1974, what is the difference between the Mineral Rent(as % of GDP) in Coal and Mineral Rent(as % of GDP) in Other Minerals?
Provide a short and direct response. -1.24. In the year 1974, what is the difference between the Mineral Rent(as % of GDP) in Natural Gas and Mineral Rent(as % of GDP) in Oil?
Make the answer very short. -6.46. In the year 1974, what is the difference between the Mineral Rent(as % of GDP) in Natural Gas and Mineral Rent(as % of GDP) in Other Minerals?
Keep it short and to the point. -1.25. In the year 1974, what is the difference between the Mineral Rent(as % of GDP) in Oil and Mineral Rent(as % of GDP) in Other Minerals?
Ensure brevity in your answer.  5.21. In the year 1975, what is the difference between the Mineral Rent(as % of GDP) in Coal and Mineral Rent(as % of GDP) in Natural Gas?
Give a very brief answer. 0.23. In the year 1975, what is the difference between the Mineral Rent(as % of GDP) of Coal and Mineral Rent(as % of GDP) of Oil?
Provide a succinct answer. -5.05. In the year 1975, what is the difference between the Mineral Rent(as % of GDP) in Coal and Mineral Rent(as % of GDP) in Other Minerals?
Give a very brief answer. -0.42. In the year 1975, what is the difference between the Mineral Rent(as % of GDP) in Natural Gas and Mineral Rent(as % of GDP) in Oil?
Offer a very short reply. -5.27. In the year 1975, what is the difference between the Mineral Rent(as % of GDP) in Natural Gas and Mineral Rent(as % of GDP) in Other Minerals?
Keep it short and to the point. -0.65. In the year 1975, what is the difference between the Mineral Rent(as % of GDP) in Oil and Mineral Rent(as % of GDP) in Other Minerals?
Your answer should be very brief. 4.63. In the year 1976, what is the difference between the Mineral Rent(as % of GDP) of Coal and Mineral Rent(as % of GDP) of Natural Gas?
Provide a succinct answer. 0.19. In the year 1976, what is the difference between the Mineral Rent(as % of GDP) in Coal and Mineral Rent(as % of GDP) in Oil?
Offer a very short reply. -5.73. In the year 1976, what is the difference between the Mineral Rent(as % of GDP) of Coal and Mineral Rent(as % of GDP) of Other Minerals?
Provide a succinct answer. -0.35. In the year 1976, what is the difference between the Mineral Rent(as % of GDP) in Natural Gas and Mineral Rent(as % of GDP) in Oil?
Offer a terse response. -5.92. In the year 1976, what is the difference between the Mineral Rent(as % of GDP) in Natural Gas and Mineral Rent(as % of GDP) in Other Minerals?
Your answer should be compact. -0.54. In the year 1976, what is the difference between the Mineral Rent(as % of GDP) in Oil and Mineral Rent(as % of GDP) in Other Minerals?
Give a very brief answer. 5.38. What is the ratio of the Mineral Rent(as % of GDP) of Coal in 1970 to that in 1971?
Give a very brief answer. 0.56. What is the ratio of the Mineral Rent(as % of GDP) in Natural Gas in 1970 to that in 1971?
Offer a very short reply. 0.9. What is the ratio of the Mineral Rent(as % of GDP) in Oil in 1970 to that in 1971?
Ensure brevity in your answer.  0.53. What is the ratio of the Mineral Rent(as % of GDP) in Other Minerals in 1970 to that in 1971?
Offer a terse response. 1.39. What is the ratio of the Mineral Rent(as % of GDP) of Coal in 1970 to that in 1972?
Give a very brief answer. 0.46. What is the ratio of the Mineral Rent(as % of GDP) in Natural Gas in 1970 to that in 1972?
Your response must be concise. 0.79. What is the ratio of the Mineral Rent(as % of GDP) of Oil in 1970 to that in 1972?
Offer a very short reply. 0.5. What is the ratio of the Mineral Rent(as % of GDP) in Other Minerals in 1970 to that in 1972?
Offer a very short reply. 1.3. What is the ratio of the Mineral Rent(as % of GDP) of Coal in 1970 to that in 1973?
Ensure brevity in your answer.  0.38. What is the ratio of the Mineral Rent(as % of GDP) in Natural Gas in 1970 to that in 1973?
Make the answer very short. 0.67. What is the ratio of the Mineral Rent(as % of GDP) in Oil in 1970 to that in 1973?
Your response must be concise. 0.33. What is the ratio of the Mineral Rent(as % of GDP) of Other Minerals in 1970 to that in 1973?
Make the answer very short. 0.76. What is the ratio of the Mineral Rent(as % of GDP) in Coal in 1970 to that in 1974?
Give a very brief answer. 0.15. What is the ratio of the Mineral Rent(as % of GDP) of Natural Gas in 1970 to that in 1974?
Offer a very short reply. 0.34. What is the ratio of the Mineral Rent(as % of GDP) in Oil in 1970 to that in 1974?
Ensure brevity in your answer.  0.1. What is the ratio of the Mineral Rent(as % of GDP) of Other Minerals in 1970 to that in 1974?
Offer a terse response. 0.56. What is the ratio of the Mineral Rent(as % of GDP) of Coal in 1970 to that in 1975?
Offer a terse response. 0.06. What is the ratio of the Mineral Rent(as % of GDP) in Natural Gas in 1970 to that in 1975?
Offer a very short reply. 0.29. What is the ratio of the Mineral Rent(as % of GDP) in Oil in 1970 to that in 1975?
Your answer should be very brief. 0.12. What is the ratio of the Mineral Rent(as % of GDP) in Other Minerals in 1970 to that in 1975?
Your response must be concise. 0.98. What is the ratio of the Mineral Rent(as % of GDP) in Coal in 1970 to that in 1976?
Keep it short and to the point. 0.06. What is the ratio of the Mineral Rent(as % of GDP) of Natural Gas in 1970 to that in 1976?
Your answer should be compact. 0.27. What is the ratio of the Mineral Rent(as % of GDP) of Oil in 1970 to that in 1976?
Ensure brevity in your answer.  0.1. What is the ratio of the Mineral Rent(as % of GDP) of Other Minerals in 1970 to that in 1976?
Your answer should be very brief. 1.11. What is the ratio of the Mineral Rent(as % of GDP) in Coal in 1971 to that in 1972?
Make the answer very short. 0.82. What is the ratio of the Mineral Rent(as % of GDP) in Natural Gas in 1971 to that in 1972?
Make the answer very short. 0.88. What is the ratio of the Mineral Rent(as % of GDP) in Oil in 1971 to that in 1972?
Your answer should be compact. 0.94. What is the ratio of the Mineral Rent(as % of GDP) in Other Minerals in 1971 to that in 1972?
Offer a very short reply. 0.94. What is the ratio of the Mineral Rent(as % of GDP) of Coal in 1971 to that in 1973?
Give a very brief answer. 0.68. What is the ratio of the Mineral Rent(as % of GDP) in Natural Gas in 1971 to that in 1973?
Ensure brevity in your answer.  0.75. What is the ratio of the Mineral Rent(as % of GDP) in Oil in 1971 to that in 1973?
Keep it short and to the point. 0.62. What is the ratio of the Mineral Rent(as % of GDP) in Other Minerals in 1971 to that in 1973?
Offer a terse response. 0.55. What is the ratio of the Mineral Rent(as % of GDP) in Coal in 1971 to that in 1974?
Your answer should be very brief. 0.28. What is the ratio of the Mineral Rent(as % of GDP) in Natural Gas in 1971 to that in 1974?
Make the answer very short. 0.37. What is the ratio of the Mineral Rent(as % of GDP) in Oil in 1971 to that in 1974?
Your answer should be very brief. 0.18. What is the ratio of the Mineral Rent(as % of GDP) of Other Minerals in 1971 to that in 1974?
Provide a short and direct response. 0.4. What is the ratio of the Mineral Rent(as % of GDP) of Coal in 1971 to that in 1975?
Your answer should be very brief. 0.1. What is the ratio of the Mineral Rent(as % of GDP) in Natural Gas in 1971 to that in 1975?
Offer a very short reply. 0.33. What is the ratio of the Mineral Rent(as % of GDP) of Oil in 1971 to that in 1975?
Offer a very short reply. 0.22. What is the ratio of the Mineral Rent(as % of GDP) in Other Minerals in 1971 to that in 1975?
Provide a succinct answer. 0.7. What is the ratio of the Mineral Rent(as % of GDP) in Coal in 1971 to that in 1976?
Your answer should be very brief. 0.11. What is the ratio of the Mineral Rent(as % of GDP) in Natural Gas in 1971 to that in 1976?
Provide a succinct answer. 0.3. What is the ratio of the Mineral Rent(as % of GDP) in Oil in 1971 to that in 1976?
Your answer should be very brief. 0.2. What is the ratio of the Mineral Rent(as % of GDP) of Other Minerals in 1971 to that in 1976?
Your answer should be very brief. 0.8. What is the ratio of the Mineral Rent(as % of GDP) in Coal in 1972 to that in 1973?
Offer a terse response. 0.83. What is the ratio of the Mineral Rent(as % of GDP) of Natural Gas in 1972 to that in 1973?
Your answer should be very brief. 0.85. What is the ratio of the Mineral Rent(as % of GDP) in Oil in 1972 to that in 1973?
Keep it short and to the point. 0.66. What is the ratio of the Mineral Rent(as % of GDP) of Other Minerals in 1972 to that in 1973?
Keep it short and to the point. 0.58. What is the ratio of the Mineral Rent(as % of GDP) in Coal in 1972 to that in 1974?
Offer a very short reply. 0.34. What is the ratio of the Mineral Rent(as % of GDP) in Natural Gas in 1972 to that in 1974?
Provide a short and direct response. 0.42. What is the ratio of the Mineral Rent(as % of GDP) in Oil in 1972 to that in 1974?
Your answer should be very brief. 0.19. What is the ratio of the Mineral Rent(as % of GDP) of Other Minerals in 1972 to that in 1974?
Provide a short and direct response. 0.43. What is the ratio of the Mineral Rent(as % of GDP) of Coal in 1972 to that in 1975?
Keep it short and to the point. 0.12. What is the ratio of the Mineral Rent(as % of GDP) in Natural Gas in 1972 to that in 1975?
Give a very brief answer. 0.37. What is the ratio of the Mineral Rent(as % of GDP) in Oil in 1972 to that in 1975?
Give a very brief answer. 0.23. What is the ratio of the Mineral Rent(as % of GDP) in Other Minerals in 1972 to that in 1975?
Make the answer very short. 0.75. What is the ratio of the Mineral Rent(as % of GDP) in Coal in 1972 to that in 1976?
Provide a succinct answer. 0.13. What is the ratio of the Mineral Rent(as % of GDP) of Natural Gas in 1972 to that in 1976?
Provide a short and direct response. 0.34. What is the ratio of the Mineral Rent(as % of GDP) in Oil in 1972 to that in 1976?
Your answer should be compact. 0.21. What is the ratio of the Mineral Rent(as % of GDP) of Other Minerals in 1972 to that in 1976?
Your response must be concise. 0.85. What is the ratio of the Mineral Rent(as % of GDP) of Coal in 1973 to that in 1974?
Provide a short and direct response. 0.4. What is the ratio of the Mineral Rent(as % of GDP) in Natural Gas in 1973 to that in 1974?
Provide a succinct answer. 0.5. What is the ratio of the Mineral Rent(as % of GDP) in Oil in 1973 to that in 1974?
Keep it short and to the point. 0.29. What is the ratio of the Mineral Rent(as % of GDP) in Other Minerals in 1973 to that in 1974?
Offer a terse response. 0.74. What is the ratio of the Mineral Rent(as % of GDP) in Coal in 1973 to that in 1975?
Give a very brief answer. 0.15. What is the ratio of the Mineral Rent(as % of GDP) in Natural Gas in 1973 to that in 1975?
Provide a short and direct response. 0.44. What is the ratio of the Mineral Rent(as % of GDP) in Oil in 1973 to that in 1975?
Offer a very short reply. 0.35. What is the ratio of the Mineral Rent(as % of GDP) of Other Minerals in 1973 to that in 1975?
Provide a short and direct response. 1.29. What is the ratio of the Mineral Rent(as % of GDP) in Coal in 1973 to that in 1976?
Your response must be concise. 0.16. What is the ratio of the Mineral Rent(as % of GDP) of Natural Gas in 1973 to that in 1976?
Your answer should be compact. 0.4. What is the ratio of the Mineral Rent(as % of GDP) in Oil in 1973 to that in 1976?
Your answer should be very brief. 0.32. What is the ratio of the Mineral Rent(as % of GDP) of Other Minerals in 1973 to that in 1976?
Your answer should be compact. 1.46. What is the ratio of the Mineral Rent(as % of GDP) in Coal in 1974 to that in 1975?
Provide a short and direct response. 0.36. What is the ratio of the Mineral Rent(as % of GDP) of Natural Gas in 1974 to that in 1975?
Keep it short and to the point. 0.88. What is the ratio of the Mineral Rent(as % of GDP) in Oil in 1974 to that in 1975?
Provide a short and direct response. 1.22. What is the ratio of the Mineral Rent(as % of GDP) of Other Minerals in 1974 to that in 1975?
Offer a very short reply. 1.75. What is the ratio of the Mineral Rent(as % of GDP) of Coal in 1974 to that in 1976?
Your answer should be very brief. 0.38. What is the ratio of the Mineral Rent(as % of GDP) of Natural Gas in 1974 to that in 1976?
Ensure brevity in your answer.  0.8. What is the ratio of the Mineral Rent(as % of GDP) of Oil in 1974 to that in 1976?
Your response must be concise. 1.08. What is the ratio of the Mineral Rent(as % of GDP) of Other Minerals in 1974 to that in 1976?
Ensure brevity in your answer.  1.98. What is the ratio of the Mineral Rent(as % of GDP) of Coal in 1975 to that in 1976?
Offer a very short reply. 1.06. What is the ratio of the Mineral Rent(as % of GDP) of Natural Gas in 1975 to that in 1976?
Your answer should be compact. 0.91. What is the ratio of the Mineral Rent(as % of GDP) of Oil in 1975 to that in 1976?
Your answer should be very brief. 0.89. What is the ratio of the Mineral Rent(as % of GDP) of Other Minerals in 1975 to that in 1976?
Make the answer very short. 1.13. What is the difference between the highest and the second highest Mineral Rent(as % of GDP) of Coal?
Ensure brevity in your answer.  0.02. What is the difference between the highest and the second highest Mineral Rent(as % of GDP) in Natural Gas?
Make the answer very short. 0.01. What is the difference between the highest and the second highest Mineral Rent(as % of GDP) of Oil?
Provide a short and direct response. 0.51. What is the difference between the highest and the second highest Mineral Rent(as % of GDP) of Other Minerals?
Offer a very short reply. 0.36. What is the difference between the highest and the lowest Mineral Rent(as % of GDP) in Coal?
Offer a terse response. 0.35. What is the difference between the highest and the lowest Mineral Rent(as % of GDP) in Natural Gas?
Your response must be concise. 0.11. What is the difference between the highest and the lowest Mineral Rent(as % of GDP) of Oil?
Ensure brevity in your answer.  5.95. What is the difference between the highest and the lowest Mineral Rent(as % of GDP) in Other Minerals?
Offer a very short reply. 0.82. 